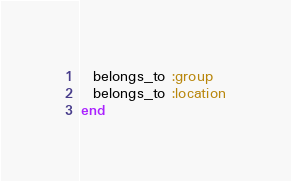<code> <loc_0><loc_0><loc_500><loc_500><_Ruby_>
  belongs_to :group
  belongs_to :location
end
</code> 